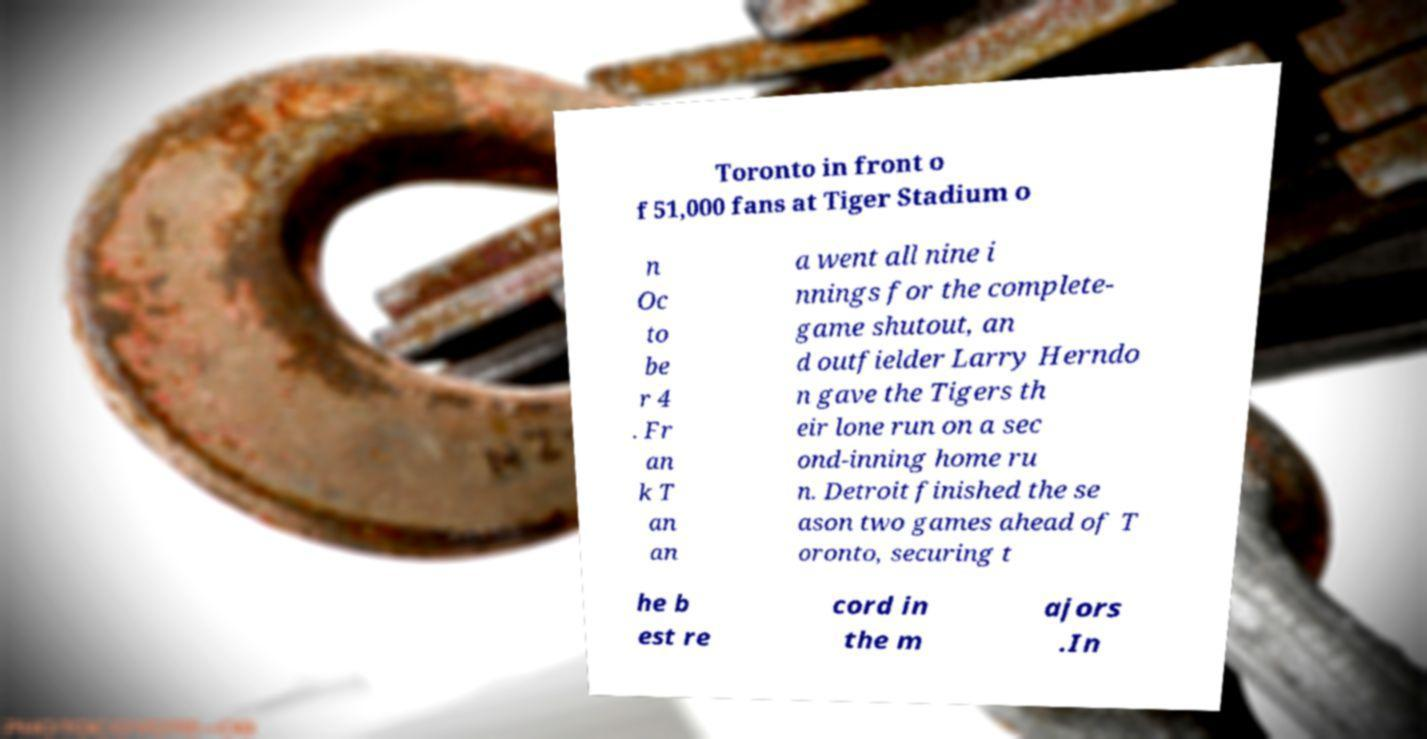Could you assist in decoding the text presented in this image and type it out clearly? Toronto in front o f 51,000 fans at Tiger Stadium o n Oc to be r 4 . Fr an k T an an a went all nine i nnings for the complete- game shutout, an d outfielder Larry Herndo n gave the Tigers th eir lone run on a sec ond-inning home ru n. Detroit finished the se ason two games ahead of T oronto, securing t he b est re cord in the m ajors .In 